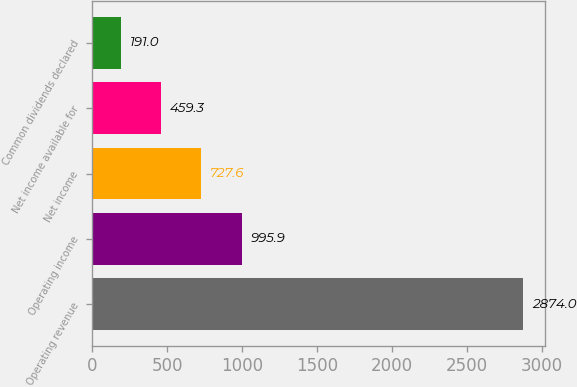Convert chart to OTSL. <chart><loc_0><loc_0><loc_500><loc_500><bar_chart><fcel>Operating revenue<fcel>Operating income<fcel>Net income<fcel>Net income available for<fcel>Common dividends declared<nl><fcel>2874<fcel>995.9<fcel>727.6<fcel>459.3<fcel>191<nl></chart> 